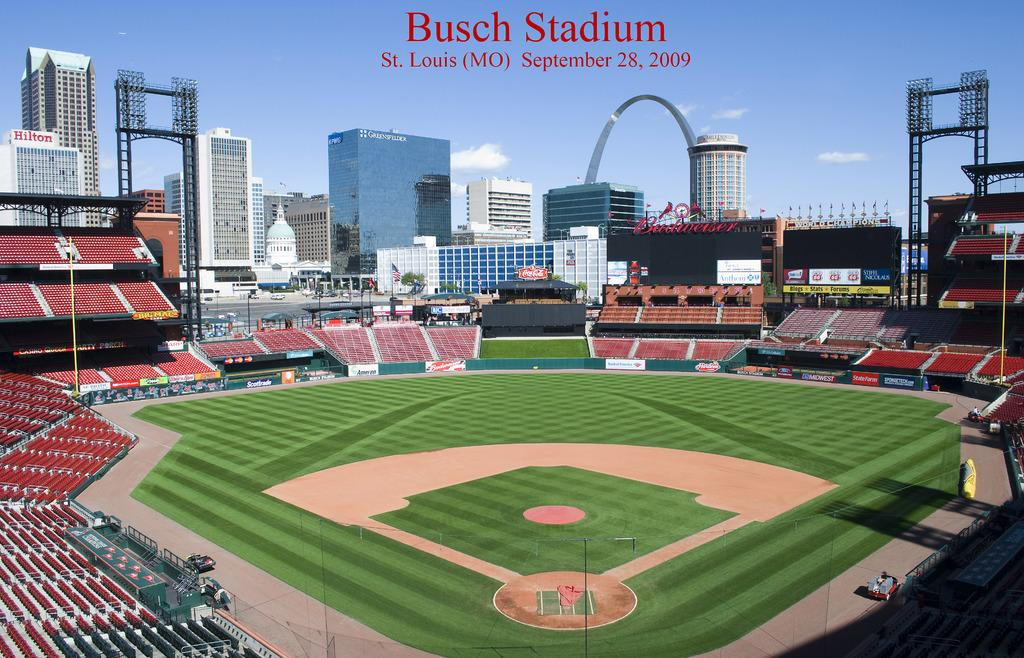Provide a one-sentence caption for the provided image. A picture of an empty Busch Stadium on September 28 2009. 